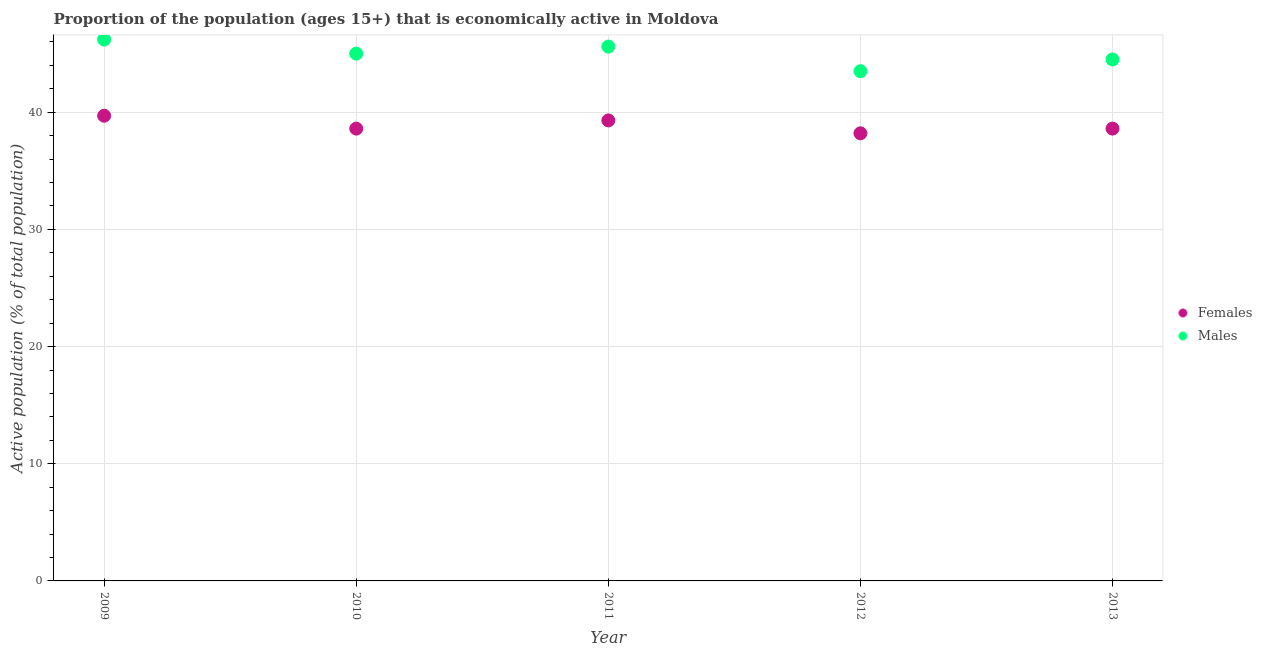Is the number of dotlines equal to the number of legend labels?
Ensure brevity in your answer.  Yes. What is the percentage of economically active female population in 2010?
Your answer should be compact. 38.6. Across all years, what is the maximum percentage of economically active female population?
Your answer should be compact. 39.7. Across all years, what is the minimum percentage of economically active male population?
Give a very brief answer. 43.5. What is the total percentage of economically active male population in the graph?
Your response must be concise. 224.8. What is the difference between the percentage of economically active female population in 2011 and that in 2013?
Give a very brief answer. 0.7. What is the difference between the percentage of economically active male population in 2012 and the percentage of economically active female population in 2009?
Your answer should be compact. 3.8. What is the average percentage of economically active male population per year?
Give a very brief answer. 44.96. In the year 2013, what is the difference between the percentage of economically active female population and percentage of economically active male population?
Provide a succinct answer. -5.9. In how many years, is the percentage of economically active male population greater than 32 %?
Provide a short and direct response. 5. What is the ratio of the percentage of economically active female population in 2009 to that in 2013?
Offer a terse response. 1.03. What is the difference between the highest and the second highest percentage of economically active female population?
Your answer should be very brief. 0.4. What is the difference between the highest and the lowest percentage of economically active female population?
Ensure brevity in your answer.  1.5. In how many years, is the percentage of economically active female population greater than the average percentage of economically active female population taken over all years?
Offer a very short reply. 2. Is the sum of the percentage of economically active male population in 2009 and 2012 greater than the maximum percentage of economically active female population across all years?
Give a very brief answer. Yes. Does the percentage of economically active female population monotonically increase over the years?
Your answer should be compact. No. How many years are there in the graph?
Offer a very short reply. 5. Does the graph contain grids?
Offer a terse response. Yes. Where does the legend appear in the graph?
Offer a terse response. Center right. How many legend labels are there?
Keep it short and to the point. 2. What is the title of the graph?
Your answer should be compact. Proportion of the population (ages 15+) that is economically active in Moldova. What is the label or title of the X-axis?
Your response must be concise. Year. What is the label or title of the Y-axis?
Offer a terse response. Active population (% of total population). What is the Active population (% of total population) of Females in 2009?
Provide a short and direct response. 39.7. What is the Active population (% of total population) in Males in 2009?
Keep it short and to the point. 46.2. What is the Active population (% of total population) in Females in 2010?
Make the answer very short. 38.6. What is the Active population (% of total population) in Males in 2010?
Ensure brevity in your answer.  45. What is the Active population (% of total population) of Females in 2011?
Your response must be concise. 39.3. What is the Active population (% of total population) in Males in 2011?
Provide a succinct answer. 45.6. What is the Active population (% of total population) in Females in 2012?
Ensure brevity in your answer.  38.2. What is the Active population (% of total population) in Males in 2012?
Keep it short and to the point. 43.5. What is the Active population (% of total population) in Females in 2013?
Your answer should be compact. 38.6. What is the Active population (% of total population) of Males in 2013?
Keep it short and to the point. 44.5. Across all years, what is the maximum Active population (% of total population) in Females?
Make the answer very short. 39.7. Across all years, what is the maximum Active population (% of total population) in Males?
Provide a succinct answer. 46.2. Across all years, what is the minimum Active population (% of total population) of Females?
Offer a terse response. 38.2. Across all years, what is the minimum Active population (% of total population) in Males?
Your answer should be compact. 43.5. What is the total Active population (% of total population) in Females in the graph?
Ensure brevity in your answer.  194.4. What is the total Active population (% of total population) of Males in the graph?
Your answer should be compact. 224.8. What is the difference between the Active population (% of total population) in Females in 2009 and that in 2010?
Make the answer very short. 1.1. What is the difference between the Active population (% of total population) in Females in 2009 and that in 2011?
Your answer should be compact. 0.4. What is the difference between the Active population (% of total population) of Males in 2009 and that in 2011?
Offer a very short reply. 0.6. What is the difference between the Active population (% of total population) in Females in 2009 and that in 2012?
Provide a short and direct response. 1.5. What is the difference between the Active population (% of total population) of Males in 2009 and that in 2012?
Ensure brevity in your answer.  2.7. What is the difference between the Active population (% of total population) of Females in 2010 and that in 2012?
Ensure brevity in your answer.  0.4. What is the difference between the Active population (% of total population) in Males in 2010 and that in 2013?
Offer a very short reply. 0.5. What is the difference between the Active population (% of total population) in Males in 2011 and that in 2012?
Offer a very short reply. 2.1. What is the difference between the Active population (% of total population) of Males in 2012 and that in 2013?
Keep it short and to the point. -1. What is the difference between the Active population (% of total population) in Females in 2009 and the Active population (% of total population) in Males in 2010?
Your response must be concise. -5.3. What is the difference between the Active population (% of total population) in Females in 2009 and the Active population (% of total population) in Males in 2013?
Offer a terse response. -4.8. What is the difference between the Active population (% of total population) in Females in 2010 and the Active population (% of total population) in Males in 2012?
Your answer should be compact. -4.9. What is the difference between the Active population (% of total population) of Females in 2010 and the Active population (% of total population) of Males in 2013?
Make the answer very short. -5.9. What is the difference between the Active population (% of total population) in Females in 2011 and the Active population (% of total population) in Males in 2012?
Your answer should be compact. -4.2. What is the average Active population (% of total population) in Females per year?
Your response must be concise. 38.88. What is the average Active population (% of total population) in Males per year?
Offer a very short reply. 44.96. What is the ratio of the Active population (% of total population) of Females in 2009 to that in 2010?
Keep it short and to the point. 1.03. What is the ratio of the Active population (% of total population) of Males in 2009 to that in 2010?
Your answer should be compact. 1.03. What is the ratio of the Active population (% of total population) of Females in 2009 to that in 2011?
Your answer should be very brief. 1.01. What is the ratio of the Active population (% of total population) in Males in 2009 to that in 2011?
Provide a short and direct response. 1.01. What is the ratio of the Active population (% of total population) in Females in 2009 to that in 2012?
Provide a short and direct response. 1.04. What is the ratio of the Active population (% of total population) of Males in 2009 to that in 2012?
Give a very brief answer. 1.06. What is the ratio of the Active population (% of total population) of Females in 2009 to that in 2013?
Give a very brief answer. 1.03. What is the ratio of the Active population (% of total population) in Males in 2009 to that in 2013?
Give a very brief answer. 1.04. What is the ratio of the Active population (% of total population) of Females in 2010 to that in 2011?
Ensure brevity in your answer.  0.98. What is the ratio of the Active population (% of total population) in Females in 2010 to that in 2012?
Offer a very short reply. 1.01. What is the ratio of the Active population (% of total population) of Males in 2010 to that in 2012?
Provide a succinct answer. 1.03. What is the ratio of the Active population (% of total population) of Males in 2010 to that in 2013?
Provide a short and direct response. 1.01. What is the ratio of the Active population (% of total population) of Females in 2011 to that in 2012?
Give a very brief answer. 1.03. What is the ratio of the Active population (% of total population) in Males in 2011 to that in 2012?
Give a very brief answer. 1.05. What is the ratio of the Active population (% of total population) in Females in 2011 to that in 2013?
Provide a short and direct response. 1.02. What is the ratio of the Active population (% of total population) of Males in 2011 to that in 2013?
Keep it short and to the point. 1.02. What is the ratio of the Active population (% of total population) in Males in 2012 to that in 2013?
Your response must be concise. 0.98. What is the difference between the highest and the second highest Active population (% of total population) in Females?
Give a very brief answer. 0.4. What is the difference between the highest and the second highest Active population (% of total population) of Males?
Give a very brief answer. 0.6. What is the difference between the highest and the lowest Active population (% of total population) in Females?
Your answer should be very brief. 1.5. What is the difference between the highest and the lowest Active population (% of total population) in Males?
Keep it short and to the point. 2.7. 